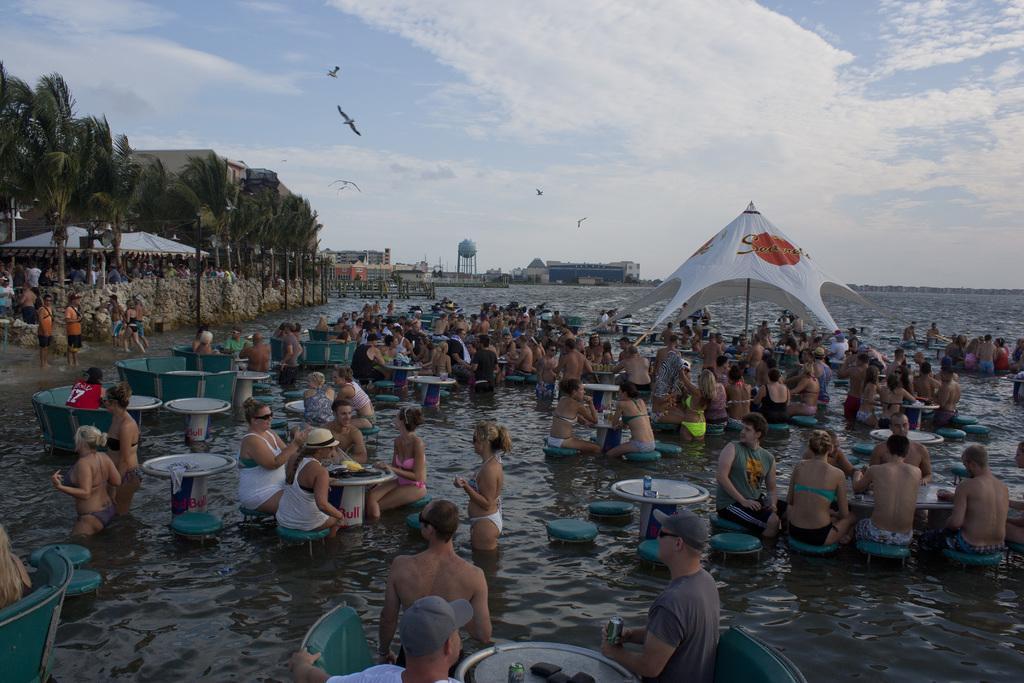Could you give a brief overview of what you see in this image? In this image there is the sea, in that sea there are tables, around the tables there are chairs, on that chairs there are people sitting, in the middle there is an umbrella, in the background there are trees, buildings and people standing and there is the sky. 